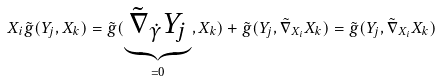Convert formula to latex. <formula><loc_0><loc_0><loc_500><loc_500>X _ { i } \tilde { g } ( Y _ { j } , X _ { k } ) = \tilde { g } ( \underbrace { \tilde { \nabla } _ { \dot { \gamma } } Y _ { j } } _ { = 0 } , X _ { k } ) + \tilde { g } ( Y _ { j } , \tilde { \nabla } _ { X _ { i } } X _ { k } ) = \tilde { g } ( Y _ { j } , \tilde { \nabla } _ { X _ { i } } X _ { k } )</formula> 